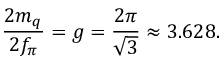Convert formula to latex. <formula><loc_0><loc_0><loc_500><loc_500>\frac { 2 m _ { q } } { 2 f _ { \pi } } = g = \frac { 2 \pi } { \sqrt { 3 } } \approx 3 . 6 2 8 .</formula> 